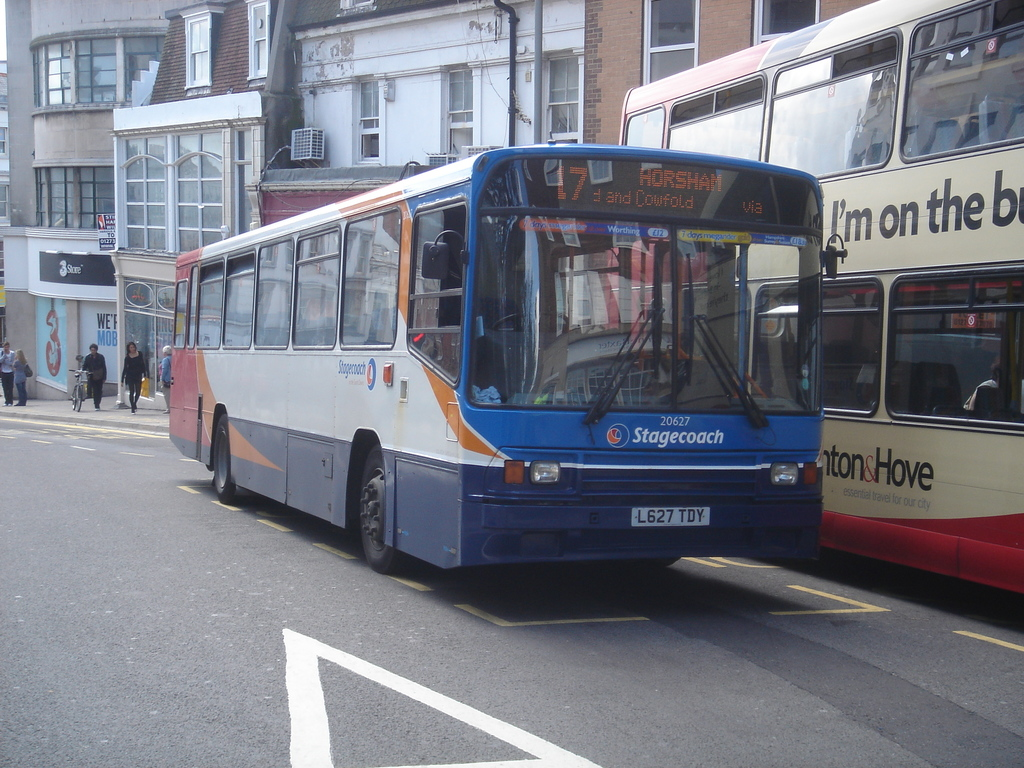Provide a one-sentence caption for the provided image.
Reference OCR token: HORS, Cowfold, I'm, on, the, b, 3SuE, lrgad, 20627, Stagecoach, tonsHove, L627TDY, L627, TDY Bus 17 passes another bus on its way to Horsham. 